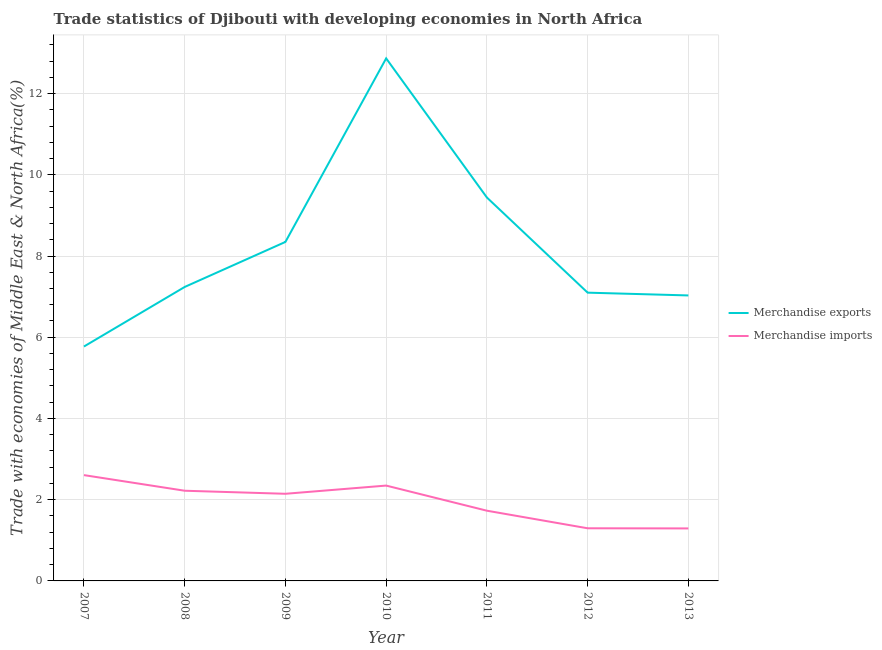Is the number of lines equal to the number of legend labels?
Offer a very short reply. Yes. What is the merchandise exports in 2013?
Offer a terse response. 7.03. Across all years, what is the maximum merchandise exports?
Ensure brevity in your answer.  12.87. Across all years, what is the minimum merchandise exports?
Make the answer very short. 5.77. In which year was the merchandise exports maximum?
Make the answer very short. 2010. In which year was the merchandise exports minimum?
Your answer should be compact. 2007. What is the total merchandise exports in the graph?
Make the answer very short. 57.79. What is the difference between the merchandise imports in 2009 and that in 2010?
Your answer should be compact. -0.2. What is the difference between the merchandise imports in 2007 and the merchandise exports in 2008?
Offer a very short reply. -4.63. What is the average merchandise imports per year?
Ensure brevity in your answer.  1.95. In the year 2007, what is the difference between the merchandise exports and merchandise imports?
Ensure brevity in your answer.  3.17. In how many years, is the merchandise imports greater than 1.2000000000000002 %?
Your response must be concise. 7. What is the ratio of the merchandise imports in 2008 to that in 2011?
Your answer should be compact. 1.28. Is the merchandise exports in 2007 less than that in 2013?
Your response must be concise. Yes. Is the difference between the merchandise imports in 2011 and 2012 greater than the difference between the merchandise exports in 2011 and 2012?
Give a very brief answer. No. What is the difference between the highest and the second highest merchandise exports?
Provide a succinct answer. 3.43. What is the difference between the highest and the lowest merchandise imports?
Offer a terse response. 1.31. In how many years, is the merchandise imports greater than the average merchandise imports taken over all years?
Keep it short and to the point. 4. Is the sum of the merchandise exports in 2010 and 2011 greater than the maximum merchandise imports across all years?
Make the answer very short. Yes. Is the merchandise exports strictly greater than the merchandise imports over the years?
Offer a very short reply. Yes. How many lines are there?
Ensure brevity in your answer.  2. How many years are there in the graph?
Your response must be concise. 7. What is the difference between two consecutive major ticks on the Y-axis?
Provide a succinct answer. 2. Does the graph contain grids?
Provide a succinct answer. Yes. How many legend labels are there?
Your answer should be compact. 2. How are the legend labels stacked?
Your answer should be very brief. Vertical. What is the title of the graph?
Offer a terse response. Trade statistics of Djibouti with developing economies in North Africa. What is the label or title of the X-axis?
Make the answer very short. Year. What is the label or title of the Y-axis?
Your answer should be compact. Trade with economies of Middle East & North Africa(%). What is the Trade with economies of Middle East & North Africa(%) in Merchandise exports in 2007?
Your answer should be very brief. 5.77. What is the Trade with economies of Middle East & North Africa(%) of Merchandise imports in 2007?
Ensure brevity in your answer.  2.61. What is the Trade with economies of Middle East & North Africa(%) in Merchandise exports in 2008?
Give a very brief answer. 7.24. What is the Trade with economies of Middle East & North Africa(%) in Merchandise imports in 2008?
Offer a very short reply. 2.22. What is the Trade with economies of Middle East & North Africa(%) in Merchandise exports in 2009?
Make the answer very short. 8.35. What is the Trade with economies of Middle East & North Africa(%) in Merchandise imports in 2009?
Offer a very short reply. 2.15. What is the Trade with economies of Middle East & North Africa(%) in Merchandise exports in 2010?
Ensure brevity in your answer.  12.87. What is the Trade with economies of Middle East & North Africa(%) in Merchandise imports in 2010?
Give a very brief answer. 2.35. What is the Trade with economies of Middle East & North Africa(%) in Merchandise exports in 2011?
Ensure brevity in your answer.  9.44. What is the Trade with economies of Middle East & North Africa(%) of Merchandise imports in 2011?
Offer a very short reply. 1.73. What is the Trade with economies of Middle East & North Africa(%) of Merchandise exports in 2012?
Provide a short and direct response. 7.1. What is the Trade with economies of Middle East & North Africa(%) in Merchandise imports in 2012?
Ensure brevity in your answer.  1.3. What is the Trade with economies of Middle East & North Africa(%) in Merchandise exports in 2013?
Keep it short and to the point. 7.03. What is the Trade with economies of Middle East & North Africa(%) of Merchandise imports in 2013?
Provide a succinct answer. 1.29. Across all years, what is the maximum Trade with economies of Middle East & North Africa(%) of Merchandise exports?
Provide a succinct answer. 12.87. Across all years, what is the maximum Trade with economies of Middle East & North Africa(%) in Merchandise imports?
Offer a terse response. 2.61. Across all years, what is the minimum Trade with economies of Middle East & North Africa(%) of Merchandise exports?
Your answer should be very brief. 5.77. Across all years, what is the minimum Trade with economies of Middle East & North Africa(%) of Merchandise imports?
Make the answer very short. 1.29. What is the total Trade with economies of Middle East & North Africa(%) of Merchandise exports in the graph?
Your answer should be compact. 57.79. What is the total Trade with economies of Middle East & North Africa(%) in Merchandise imports in the graph?
Your response must be concise. 13.64. What is the difference between the Trade with economies of Middle East & North Africa(%) in Merchandise exports in 2007 and that in 2008?
Offer a very short reply. -1.47. What is the difference between the Trade with economies of Middle East & North Africa(%) in Merchandise imports in 2007 and that in 2008?
Provide a succinct answer. 0.38. What is the difference between the Trade with economies of Middle East & North Africa(%) in Merchandise exports in 2007 and that in 2009?
Make the answer very short. -2.58. What is the difference between the Trade with economies of Middle East & North Africa(%) in Merchandise imports in 2007 and that in 2009?
Your answer should be very brief. 0.46. What is the difference between the Trade with economies of Middle East & North Africa(%) in Merchandise exports in 2007 and that in 2010?
Make the answer very short. -7.1. What is the difference between the Trade with economies of Middle East & North Africa(%) of Merchandise imports in 2007 and that in 2010?
Give a very brief answer. 0.26. What is the difference between the Trade with economies of Middle East & North Africa(%) in Merchandise exports in 2007 and that in 2011?
Your response must be concise. -3.67. What is the difference between the Trade with economies of Middle East & North Africa(%) of Merchandise imports in 2007 and that in 2011?
Ensure brevity in your answer.  0.88. What is the difference between the Trade with economies of Middle East & North Africa(%) of Merchandise exports in 2007 and that in 2012?
Your answer should be very brief. -1.33. What is the difference between the Trade with economies of Middle East & North Africa(%) in Merchandise imports in 2007 and that in 2012?
Ensure brevity in your answer.  1.31. What is the difference between the Trade with economies of Middle East & North Africa(%) of Merchandise exports in 2007 and that in 2013?
Provide a succinct answer. -1.26. What is the difference between the Trade with economies of Middle East & North Africa(%) of Merchandise imports in 2007 and that in 2013?
Offer a very short reply. 1.31. What is the difference between the Trade with economies of Middle East & North Africa(%) of Merchandise exports in 2008 and that in 2009?
Provide a short and direct response. -1.11. What is the difference between the Trade with economies of Middle East & North Africa(%) of Merchandise imports in 2008 and that in 2009?
Ensure brevity in your answer.  0.08. What is the difference between the Trade with economies of Middle East & North Africa(%) of Merchandise exports in 2008 and that in 2010?
Keep it short and to the point. -5.63. What is the difference between the Trade with economies of Middle East & North Africa(%) in Merchandise imports in 2008 and that in 2010?
Your response must be concise. -0.13. What is the difference between the Trade with economies of Middle East & North Africa(%) in Merchandise exports in 2008 and that in 2011?
Offer a very short reply. -2.2. What is the difference between the Trade with economies of Middle East & North Africa(%) of Merchandise imports in 2008 and that in 2011?
Provide a succinct answer. 0.49. What is the difference between the Trade with economies of Middle East & North Africa(%) of Merchandise exports in 2008 and that in 2012?
Your answer should be very brief. 0.14. What is the difference between the Trade with economies of Middle East & North Africa(%) in Merchandise imports in 2008 and that in 2012?
Offer a terse response. 0.92. What is the difference between the Trade with economies of Middle East & North Africa(%) in Merchandise exports in 2008 and that in 2013?
Provide a short and direct response. 0.21. What is the difference between the Trade with economies of Middle East & North Africa(%) of Merchandise imports in 2008 and that in 2013?
Keep it short and to the point. 0.93. What is the difference between the Trade with economies of Middle East & North Africa(%) in Merchandise exports in 2009 and that in 2010?
Provide a short and direct response. -4.52. What is the difference between the Trade with economies of Middle East & North Africa(%) in Merchandise imports in 2009 and that in 2010?
Offer a very short reply. -0.2. What is the difference between the Trade with economies of Middle East & North Africa(%) of Merchandise exports in 2009 and that in 2011?
Your response must be concise. -1.09. What is the difference between the Trade with economies of Middle East & North Africa(%) in Merchandise imports in 2009 and that in 2011?
Make the answer very short. 0.42. What is the difference between the Trade with economies of Middle East & North Africa(%) in Merchandise exports in 2009 and that in 2012?
Provide a succinct answer. 1.25. What is the difference between the Trade with economies of Middle East & North Africa(%) of Merchandise imports in 2009 and that in 2012?
Offer a terse response. 0.85. What is the difference between the Trade with economies of Middle East & North Africa(%) of Merchandise exports in 2009 and that in 2013?
Provide a succinct answer. 1.32. What is the difference between the Trade with economies of Middle East & North Africa(%) of Merchandise imports in 2009 and that in 2013?
Keep it short and to the point. 0.85. What is the difference between the Trade with economies of Middle East & North Africa(%) of Merchandise exports in 2010 and that in 2011?
Your answer should be compact. 3.43. What is the difference between the Trade with economies of Middle East & North Africa(%) in Merchandise imports in 2010 and that in 2011?
Keep it short and to the point. 0.62. What is the difference between the Trade with economies of Middle East & North Africa(%) in Merchandise exports in 2010 and that in 2012?
Keep it short and to the point. 5.77. What is the difference between the Trade with economies of Middle East & North Africa(%) of Merchandise imports in 2010 and that in 2012?
Give a very brief answer. 1.05. What is the difference between the Trade with economies of Middle East & North Africa(%) in Merchandise exports in 2010 and that in 2013?
Make the answer very short. 5.84. What is the difference between the Trade with economies of Middle East & North Africa(%) of Merchandise imports in 2010 and that in 2013?
Offer a very short reply. 1.05. What is the difference between the Trade with economies of Middle East & North Africa(%) in Merchandise exports in 2011 and that in 2012?
Make the answer very short. 2.34. What is the difference between the Trade with economies of Middle East & North Africa(%) of Merchandise imports in 2011 and that in 2012?
Offer a terse response. 0.43. What is the difference between the Trade with economies of Middle East & North Africa(%) in Merchandise exports in 2011 and that in 2013?
Your answer should be very brief. 2.41. What is the difference between the Trade with economies of Middle East & North Africa(%) in Merchandise imports in 2011 and that in 2013?
Give a very brief answer. 0.44. What is the difference between the Trade with economies of Middle East & North Africa(%) in Merchandise exports in 2012 and that in 2013?
Keep it short and to the point. 0.07. What is the difference between the Trade with economies of Middle East & North Africa(%) of Merchandise imports in 2012 and that in 2013?
Offer a terse response. 0. What is the difference between the Trade with economies of Middle East & North Africa(%) of Merchandise exports in 2007 and the Trade with economies of Middle East & North Africa(%) of Merchandise imports in 2008?
Provide a short and direct response. 3.55. What is the difference between the Trade with economies of Middle East & North Africa(%) in Merchandise exports in 2007 and the Trade with economies of Middle East & North Africa(%) in Merchandise imports in 2009?
Provide a succinct answer. 3.63. What is the difference between the Trade with economies of Middle East & North Africa(%) of Merchandise exports in 2007 and the Trade with economies of Middle East & North Africa(%) of Merchandise imports in 2010?
Ensure brevity in your answer.  3.42. What is the difference between the Trade with economies of Middle East & North Africa(%) of Merchandise exports in 2007 and the Trade with economies of Middle East & North Africa(%) of Merchandise imports in 2011?
Ensure brevity in your answer.  4.04. What is the difference between the Trade with economies of Middle East & North Africa(%) of Merchandise exports in 2007 and the Trade with economies of Middle East & North Africa(%) of Merchandise imports in 2012?
Your response must be concise. 4.48. What is the difference between the Trade with economies of Middle East & North Africa(%) in Merchandise exports in 2007 and the Trade with economies of Middle East & North Africa(%) in Merchandise imports in 2013?
Ensure brevity in your answer.  4.48. What is the difference between the Trade with economies of Middle East & North Africa(%) in Merchandise exports in 2008 and the Trade with economies of Middle East & North Africa(%) in Merchandise imports in 2009?
Provide a succinct answer. 5.09. What is the difference between the Trade with economies of Middle East & North Africa(%) of Merchandise exports in 2008 and the Trade with economies of Middle East & North Africa(%) of Merchandise imports in 2010?
Keep it short and to the point. 4.89. What is the difference between the Trade with economies of Middle East & North Africa(%) of Merchandise exports in 2008 and the Trade with economies of Middle East & North Africa(%) of Merchandise imports in 2011?
Offer a terse response. 5.51. What is the difference between the Trade with economies of Middle East & North Africa(%) in Merchandise exports in 2008 and the Trade with economies of Middle East & North Africa(%) in Merchandise imports in 2012?
Make the answer very short. 5.94. What is the difference between the Trade with economies of Middle East & North Africa(%) in Merchandise exports in 2008 and the Trade with economies of Middle East & North Africa(%) in Merchandise imports in 2013?
Keep it short and to the point. 5.95. What is the difference between the Trade with economies of Middle East & North Africa(%) in Merchandise exports in 2009 and the Trade with economies of Middle East & North Africa(%) in Merchandise imports in 2010?
Provide a succinct answer. 6. What is the difference between the Trade with economies of Middle East & North Africa(%) of Merchandise exports in 2009 and the Trade with economies of Middle East & North Africa(%) of Merchandise imports in 2011?
Make the answer very short. 6.62. What is the difference between the Trade with economies of Middle East & North Africa(%) of Merchandise exports in 2009 and the Trade with economies of Middle East & North Africa(%) of Merchandise imports in 2012?
Ensure brevity in your answer.  7.05. What is the difference between the Trade with economies of Middle East & North Africa(%) in Merchandise exports in 2009 and the Trade with economies of Middle East & North Africa(%) in Merchandise imports in 2013?
Keep it short and to the point. 7.05. What is the difference between the Trade with economies of Middle East & North Africa(%) of Merchandise exports in 2010 and the Trade with economies of Middle East & North Africa(%) of Merchandise imports in 2011?
Keep it short and to the point. 11.14. What is the difference between the Trade with economies of Middle East & North Africa(%) of Merchandise exports in 2010 and the Trade with economies of Middle East & North Africa(%) of Merchandise imports in 2012?
Offer a very short reply. 11.57. What is the difference between the Trade with economies of Middle East & North Africa(%) of Merchandise exports in 2010 and the Trade with economies of Middle East & North Africa(%) of Merchandise imports in 2013?
Keep it short and to the point. 11.57. What is the difference between the Trade with economies of Middle East & North Africa(%) of Merchandise exports in 2011 and the Trade with economies of Middle East & North Africa(%) of Merchandise imports in 2012?
Offer a terse response. 8.14. What is the difference between the Trade with economies of Middle East & North Africa(%) of Merchandise exports in 2011 and the Trade with economies of Middle East & North Africa(%) of Merchandise imports in 2013?
Make the answer very short. 8.15. What is the difference between the Trade with economies of Middle East & North Africa(%) in Merchandise exports in 2012 and the Trade with economies of Middle East & North Africa(%) in Merchandise imports in 2013?
Provide a succinct answer. 5.8. What is the average Trade with economies of Middle East & North Africa(%) of Merchandise exports per year?
Offer a very short reply. 8.26. What is the average Trade with economies of Middle East & North Africa(%) of Merchandise imports per year?
Your response must be concise. 1.95. In the year 2007, what is the difference between the Trade with economies of Middle East & North Africa(%) of Merchandise exports and Trade with economies of Middle East & North Africa(%) of Merchandise imports?
Ensure brevity in your answer.  3.17. In the year 2008, what is the difference between the Trade with economies of Middle East & North Africa(%) in Merchandise exports and Trade with economies of Middle East & North Africa(%) in Merchandise imports?
Provide a short and direct response. 5.02. In the year 2009, what is the difference between the Trade with economies of Middle East & North Africa(%) of Merchandise exports and Trade with economies of Middle East & North Africa(%) of Merchandise imports?
Provide a short and direct response. 6.2. In the year 2010, what is the difference between the Trade with economies of Middle East & North Africa(%) in Merchandise exports and Trade with economies of Middle East & North Africa(%) in Merchandise imports?
Keep it short and to the point. 10.52. In the year 2011, what is the difference between the Trade with economies of Middle East & North Africa(%) in Merchandise exports and Trade with economies of Middle East & North Africa(%) in Merchandise imports?
Your answer should be compact. 7.71. In the year 2012, what is the difference between the Trade with economies of Middle East & North Africa(%) of Merchandise exports and Trade with economies of Middle East & North Africa(%) of Merchandise imports?
Give a very brief answer. 5.8. In the year 2013, what is the difference between the Trade with economies of Middle East & North Africa(%) in Merchandise exports and Trade with economies of Middle East & North Africa(%) in Merchandise imports?
Offer a very short reply. 5.74. What is the ratio of the Trade with economies of Middle East & North Africa(%) of Merchandise exports in 2007 to that in 2008?
Offer a very short reply. 0.8. What is the ratio of the Trade with economies of Middle East & North Africa(%) of Merchandise imports in 2007 to that in 2008?
Offer a very short reply. 1.17. What is the ratio of the Trade with economies of Middle East & North Africa(%) of Merchandise exports in 2007 to that in 2009?
Your answer should be compact. 0.69. What is the ratio of the Trade with economies of Middle East & North Africa(%) in Merchandise imports in 2007 to that in 2009?
Provide a short and direct response. 1.21. What is the ratio of the Trade with economies of Middle East & North Africa(%) of Merchandise exports in 2007 to that in 2010?
Your answer should be very brief. 0.45. What is the ratio of the Trade with economies of Middle East & North Africa(%) of Merchandise imports in 2007 to that in 2010?
Provide a short and direct response. 1.11. What is the ratio of the Trade with economies of Middle East & North Africa(%) of Merchandise exports in 2007 to that in 2011?
Make the answer very short. 0.61. What is the ratio of the Trade with economies of Middle East & North Africa(%) in Merchandise imports in 2007 to that in 2011?
Your answer should be very brief. 1.51. What is the ratio of the Trade with economies of Middle East & North Africa(%) of Merchandise exports in 2007 to that in 2012?
Offer a very short reply. 0.81. What is the ratio of the Trade with economies of Middle East & North Africa(%) in Merchandise imports in 2007 to that in 2012?
Your answer should be compact. 2.01. What is the ratio of the Trade with economies of Middle East & North Africa(%) of Merchandise exports in 2007 to that in 2013?
Keep it short and to the point. 0.82. What is the ratio of the Trade with economies of Middle East & North Africa(%) in Merchandise imports in 2007 to that in 2013?
Provide a succinct answer. 2.02. What is the ratio of the Trade with economies of Middle East & North Africa(%) of Merchandise exports in 2008 to that in 2009?
Offer a terse response. 0.87. What is the ratio of the Trade with economies of Middle East & North Africa(%) of Merchandise imports in 2008 to that in 2009?
Provide a short and direct response. 1.04. What is the ratio of the Trade with economies of Middle East & North Africa(%) of Merchandise exports in 2008 to that in 2010?
Offer a terse response. 0.56. What is the ratio of the Trade with economies of Middle East & North Africa(%) of Merchandise imports in 2008 to that in 2010?
Ensure brevity in your answer.  0.95. What is the ratio of the Trade with economies of Middle East & North Africa(%) in Merchandise exports in 2008 to that in 2011?
Your answer should be very brief. 0.77. What is the ratio of the Trade with economies of Middle East & North Africa(%) of Merchandise imports in 2008 to that in 2011?
Offer a very short reply. 1.28. What is the ratio of the Trade with economies of Middle East & North Africa(%) of Merchandise exports in 2008 to that in 2012?
Offer a very short reply. 1.02. What is the ratio of the Trade with economies of Middle East & North Africa(%) of Merchandise imports in 2008 to that in 2012?
Make the answer very short. 1.71. What is the ratio of the Trade with economies of Middle East & North Africa(%) of Merchandise exports in 2008 to that in 2013?
Provide a short and direct response. 1.03. What is the ratio of the Trade with economies of Middle East & North Africa(%) of Merchandise imports in 2008 to that in 2013?
Provide a short and direct response. 1.72. What is the ratio of the Trade with economies of Middle East & North Africa(%) of Merchandise exports in 2009 to that in 2010?
Give a very brief answer. 0.65. What is the ratio of the Trade with economies of Middle East & North Africa(%) in Merchandise imports in 2009 to that in 2010?
Make the answer very short. 0.91. What is the ratio of the Trade with economies of Middle East & North Africa(%) of Merchandise exports in 2009 to that in 2011?
Your answer should be compact. 0.88. What is the ratio of the Trade with economies of Middle East & North Africa(%) of Merchandise imports in 2009 to that in 2011?
Keep it short and to the point. 1.24. What is the ratio of the Trade with economies of Middle East & North Africa(%) in Merchandise exports in 2009 to that in 2012?
Provide a succinct answer. 1.18. What is the ratio of the Trade with economies of Middle East & North Africa(%) of Merchandise imports in 2009 to that in 2012?
Keep it short and to the point. 1.66. What is the ratio of the Trade with economies of Middle East & North Africa(%) in Merchandise exports in 2009 to that in 2013?
Your answer should be very brief. 1.19. What is the ratio of the Trade with economies of Middle East & North Africa(%) in Merchandise imports in 2009 to that in 2013?
Ensure brevity in your answer.  1.66. What is the ratio of the Trade with economies of Middle East & North Africa(%) in Merchandise exports in 2010 to that in 2011?
Your answer should be compact. 1.36. What is the ratio of the Trade with economies of Middle East & North Africa(%) in Merchandise imports in 2010 to that in 2011?
Your answer should be compact. 1.36. What is the ratio of the Trade with economies of Middle East & North Africa(%) of Merchandise exports in 2010 to that in 2012?
Offer a terse response. 1.81. What is the ratio of the Trade with economies of Middle East & North Africa(%) of Merchandise imports in 2010 to that in 2012?
Ensure brevity in your answer.  1.81. What is the ratio of the Trade with economies of Middle East & North Africa(%) in Merchandise exports in 2010 to that in 2013?
Offer a very short reply. 1.83. What is the ratio of the Trade with economies of Middle East & North Africa(%) of Merchandise imports in 2010 to that in 2013?
Give a very brief answer. 1.82. What is the ratio of the Trade with economies of Middle East & North Africa(%) in Merchandise exports in 2011 to that in 2012?
Make the answer very short. 1.33. What is the ratio of the Trade with economies of Middle East & North Africa(%) of Merchandise imports in 2011 to that in 2012?
Offer a terse response. 1.33. What is the ratio of the Trade with economies of Middle East & North Africa(%) in Merchandise exports in 2011 to that in 2013?
Offer a very short reply. 1.34. What is the ratio of the Trade with economies of Middle East & North Africa(%) in Merchandise imports in 2011 to that in 2013?
Give a very brief answer. 1.34. What is the ratio of the Trade with economies of Middle East & North Africa(%) in Merchandise exports in 2012 to that in 2013?
Make the answer very short. 1.01. What is the difference between the highest and the second highest Trade with economies of Middle East & North Africa(%) of Merchandise exports?
Provide a short and direct response. 3.43. What is the difference between the highest and the second highest Trade with economies of Middle East & North Africa(%) of Merchandise imports?
Your answer should be very brief. 0.26. What is the difference between the highest and the lowest Trade with economies of Middle East & North Africa(%) in Merchandise exports?
Provide a short and direct response. 7.1. What is the difference between the highest and the lowest Trade with economies of Middle East & North Africa(%) in Merchandise imports?
Offer a terse response. 1.31. 